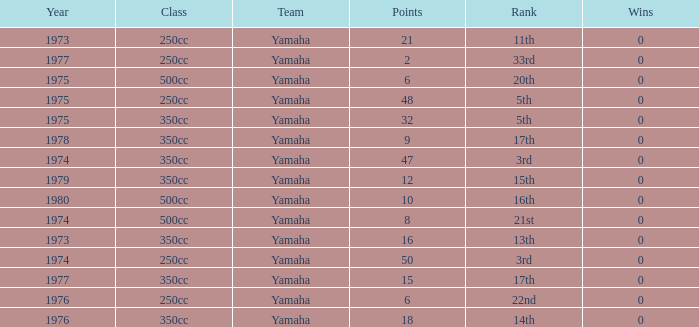Which Wins is the highest one that has a Class of 500cc, and Points smaller than 6? None. 